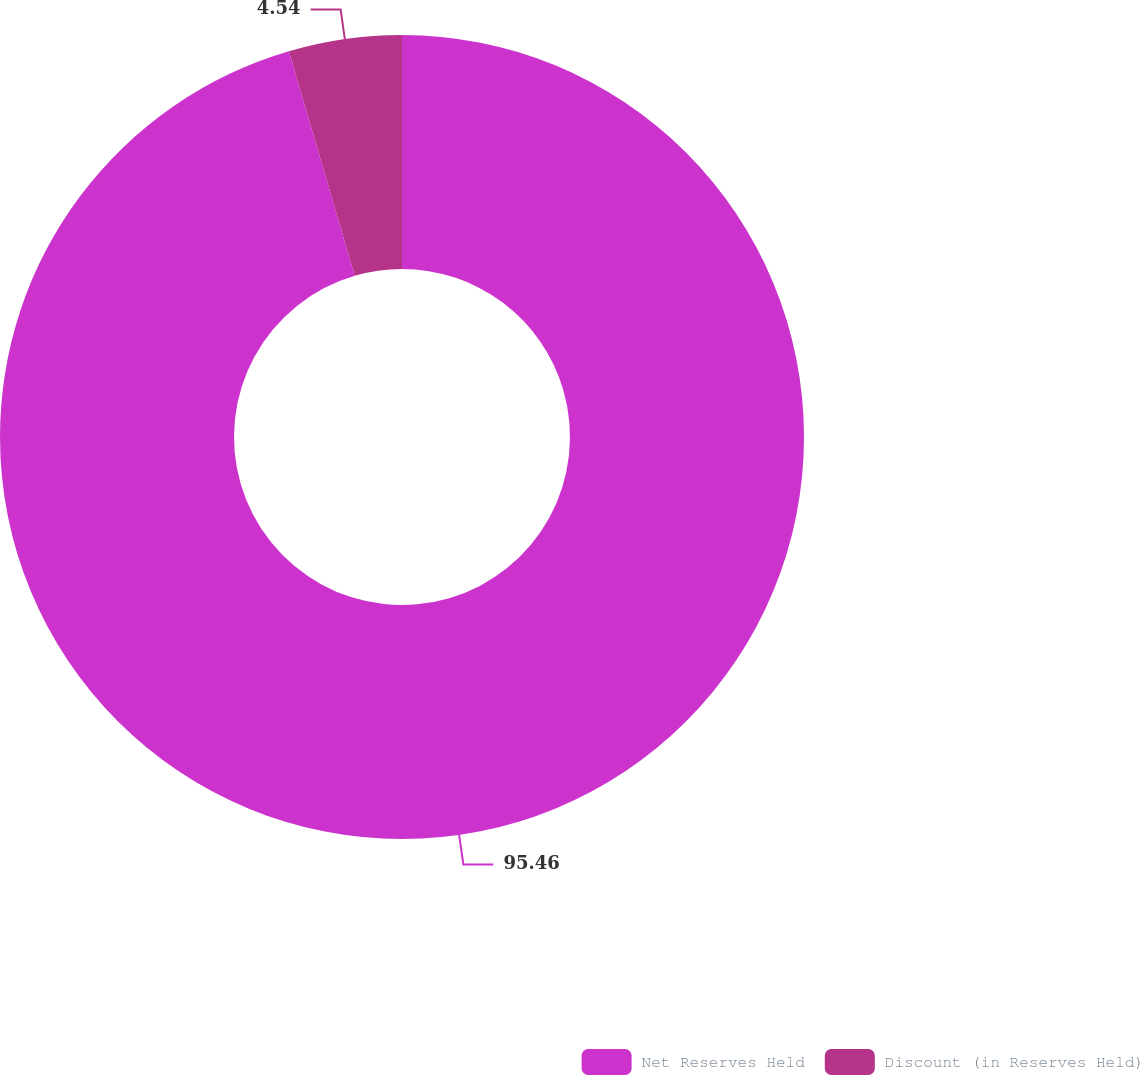Convert chart. <chart><loc_0><loc_0><loc_500><loc_500><pie_chart><fcel>Net Reserves Held<fcel>Discount (in Reserves Held)<nl><fcel>95.46%<fcel>4.54%<nl></chart> 